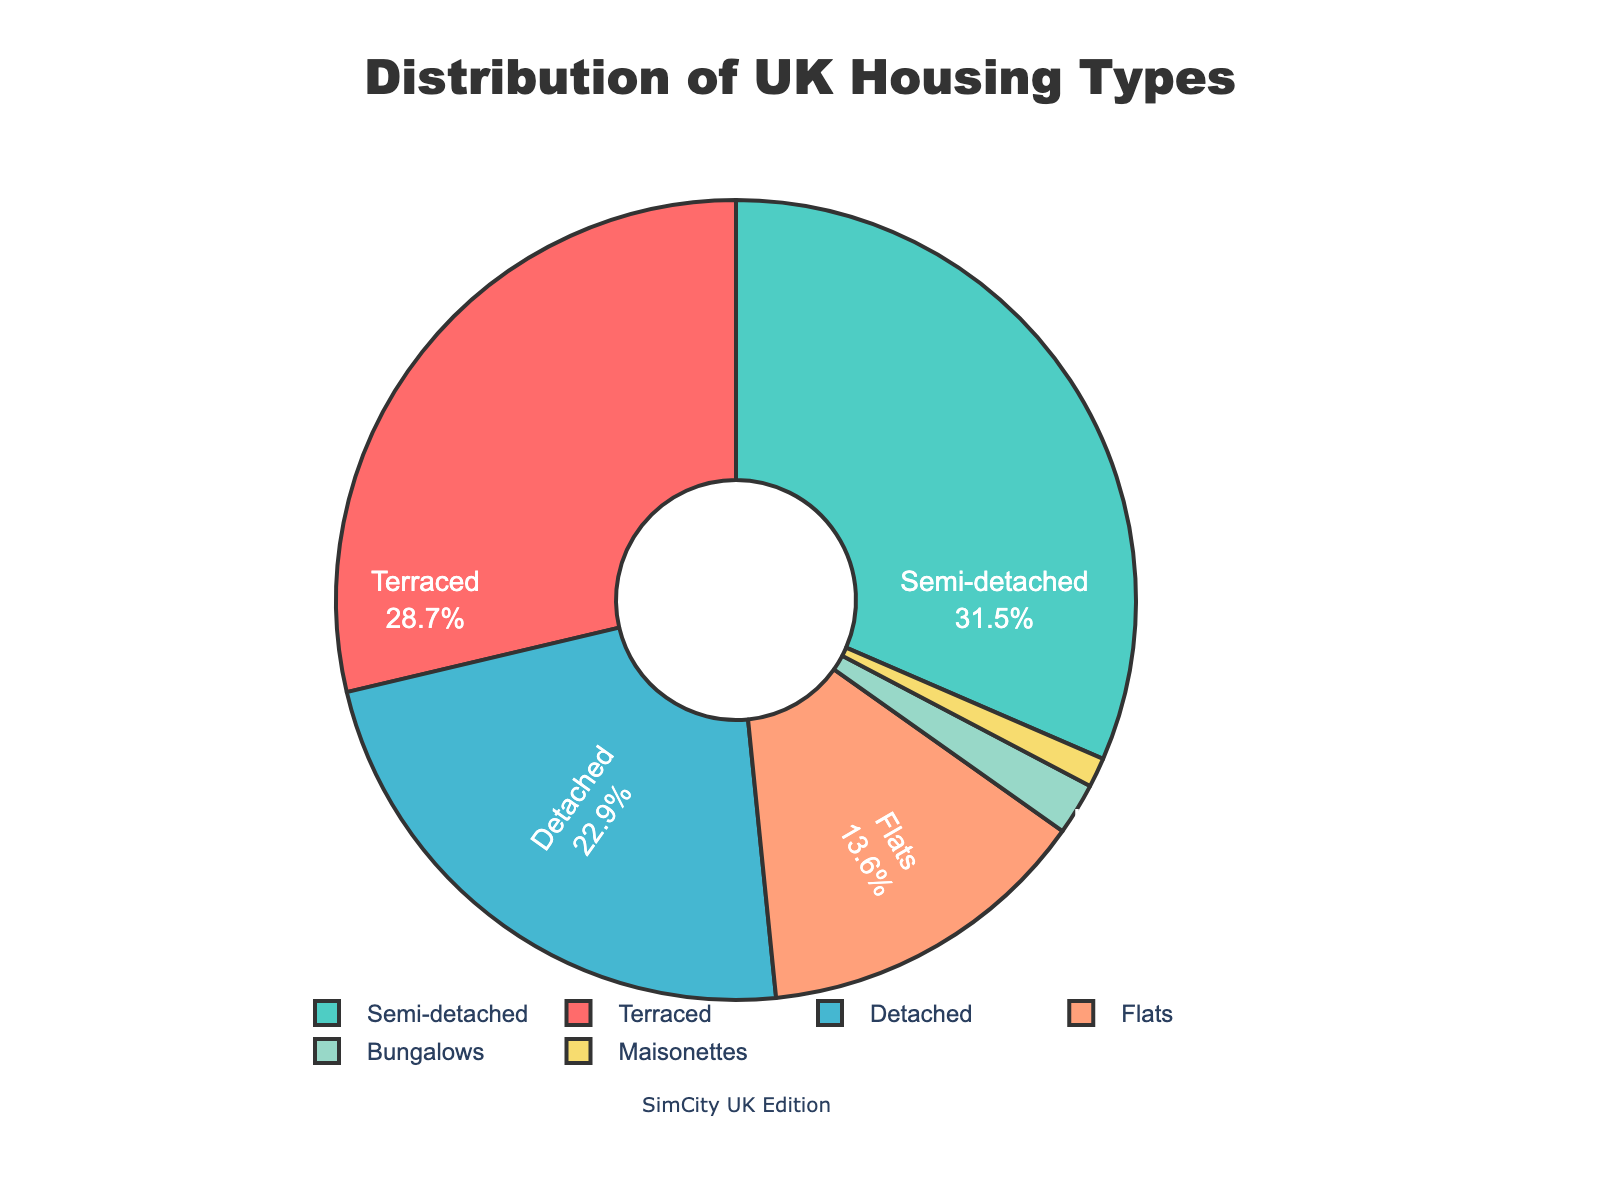What percentage of UK housing types are semi-detached and detached combined? Add the percentage values for semi-detached (31.5%) and detached (22.9%). 31.5 + 22.9 = 54.4
Answer: 54.4% Which type of housing has the least representation? The housing types are shown with their percentages. The type with the smallest value is Maisonettes at 1.2%.
Answer: Maisonettes What is the difference in percentage between terraced and flats housing? The percentage for terraced housing is 28.7% and for flats is 13.6%. Subtract the flats percentage from the terraced: 28.7 - 13.6 = 15.1
Answer: 15.1% Is the percentage of bungalows more than or less than 3%? The percentage for bungalows is given as 2.1%. This is less than 3%.
Answer: Less than Among the housing types, which one has a percentage closest to 30%? By comparing percentages, semi-detached housing has a percentage of 31.5%, closest to 30%.
Answer: Semi-detached Among the colors used in the pie chart, which color represents terraced housing? Terraced housing is represented by the first segment, which is in red.
Answer: Red Arrange the housing types in descending order of their percentages. Ordered percentages from highest to lowest are: Semi-detached 31.5%, Terraced 28.7%, Detached 22.9%, Flats 13.6%, Bungalows 2.1%, Maisonettes 1.2%.
Answer: Semi-detached, Terraced, Detached, Flats, Bungalows, Maisonettes What is the combined percentage of terraced, flats, and maisonettes? Add the percentages for terraced (28.7%), flats (13.6%), and maisonettes (1.2%). 28.7 + 13.6 + 1.2 = 43.5
Answer: 43.5% What percentage of housing types are not flats? Subtract the percentage of flats from the total (100%). 100 - 13.6 = 86.4
Answer: 86.4% 